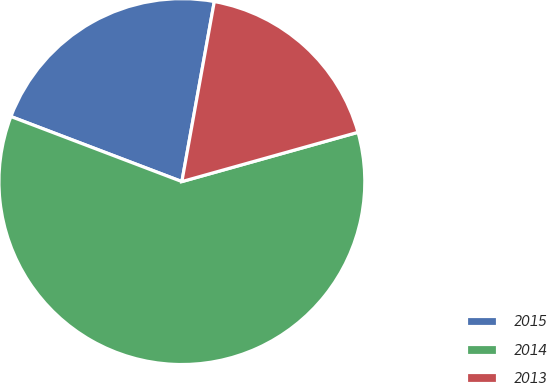Convert chart to OTSL. <chart><loc_0><loc_0><loc_500><loc_500><pie_chart><fcel>2015<fcel>2014<fcel>2013<nl><fcel>22.05%<fcel>60.13%<fcel>17.82%<nl></chart> 